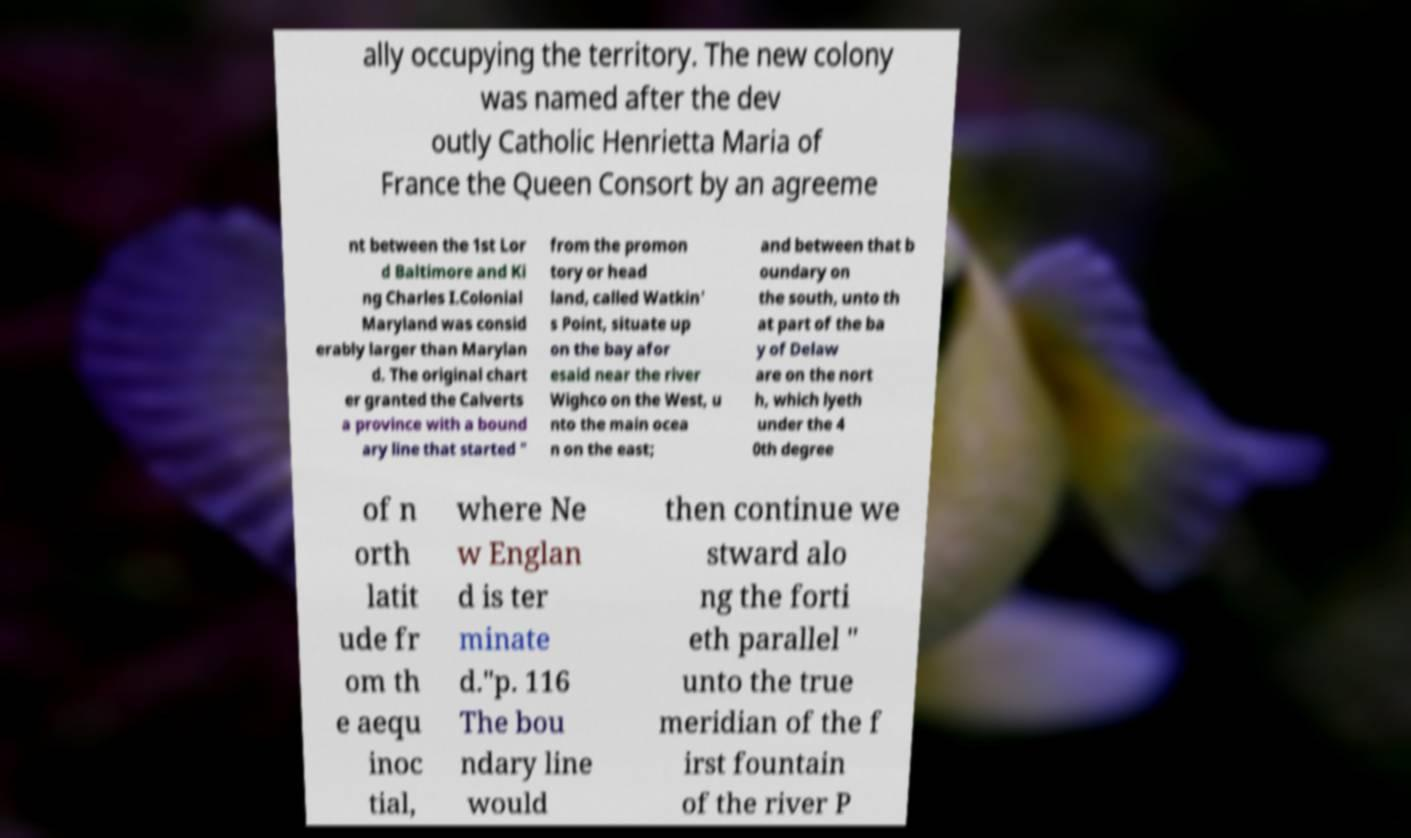Please read and relay the text visible in this image. What does it say? ally occupying the territory. The new colony was named after the dev outly Catholic Henrietta Maria of France the Queen Consort by an agreeme nt between the 1st Lor d Baltimore and Ki ng Charles I.Colonial Maryland was consid erably larger than Marylan d. The original chart er granted the Calverts a province with a bound ary line that started " from the promon tory or head land, called Watkin' s Point, situate up on the bay afor esaid near the river Wighco on the West, u nto the main ocea n on the east; and between that b oundary on the south, unto th at part of the ba y of Delaw are on the nort h, which lyeth under the 4 0th degree of n orth latit ude fr om th e aequ inoc tial, where Ne w Englan d is ter minate d."p. 116 The bou ndary line would then continue we stward alo ng the forti eth parallel " unto the true meridian of the f irst fountain of the river P 